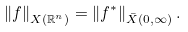<formula> <loc_0><loc_0><loc_500><loc_500>\left \| f \right \| _ { X ( \mathbb { R } ^ { n } ) } = \left \| f ^ { \ast } \right \| _ { \bar { X } ( 0 , \infty ) } .</formula> 